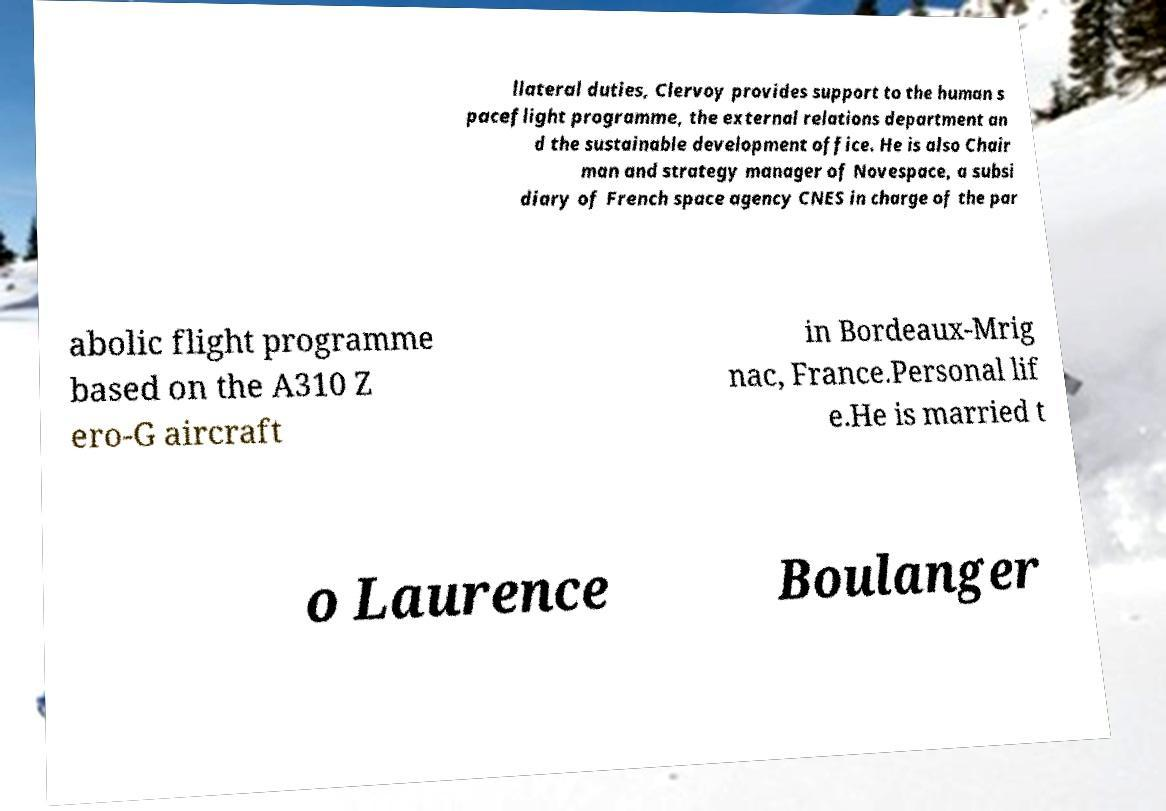Please identify and transcribe the text found in this image. llateral duties, Clervoy provides support to the human s paceflight programme, the external relations department an d the sustainable development office. He is also Chair man and strategy manager of Novespace, a subsi diary of French space agency CNES in charge of the par abolic flight programme based on the A310 Z ero-G aircraft in Bordeaux-Mrig nac, France.Personal lif e.He is married t o Laurence Boulanger 